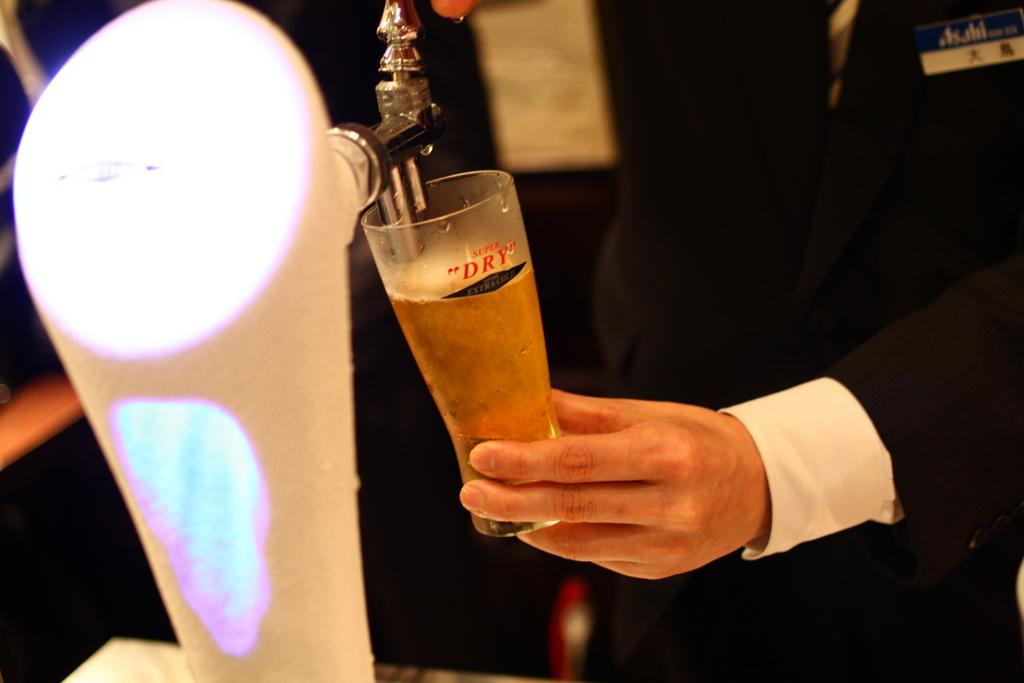<image>
Provide a brief description of the given image. A man fills up a cold glass that says super dry with beer. 